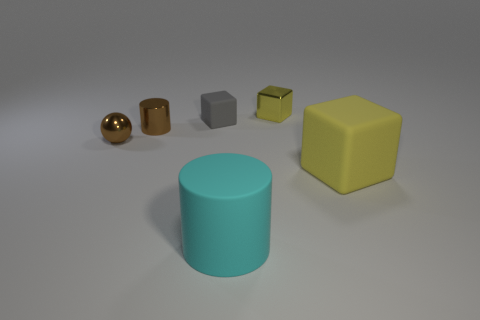There is a rubber thing that is both to the left of the big yellow cube and behind the big matte cylinder; how big is it?
Provide a succinct answer. Small. What is the shape of the gray rubber thing?
Provide a short and direct response. Cube. Does the large yellow block have the same material as the gray cube?
Offer a very short reply. Yes. The rubber cube that is the same color as the shiny cube is what size?
Offer a very short reply. Large. What shape is the large yellow thing in front of the gray object?
Provide a short and direct response. Cube. There is a matte cube that is in front of the gray rubber block; is it the same color as the shiny block?
Provide a succinct answer. Yes. There is a tiny cylinder that is the same color as the tiny metallic ball; what is its material?
Keep it short and to the point. Metal. Does the shiny cylinder behind the yellow matte object have the same size as the yellow rubber cube?
Ensure brevity in your answer.  No. Are there any small rubber blocks of the same color as the ball?
Give a very brief answer. No. There is a rubber block in front of the small gray matte block; are there any cubes behind it?
Your answer should be very brief. Yes. 